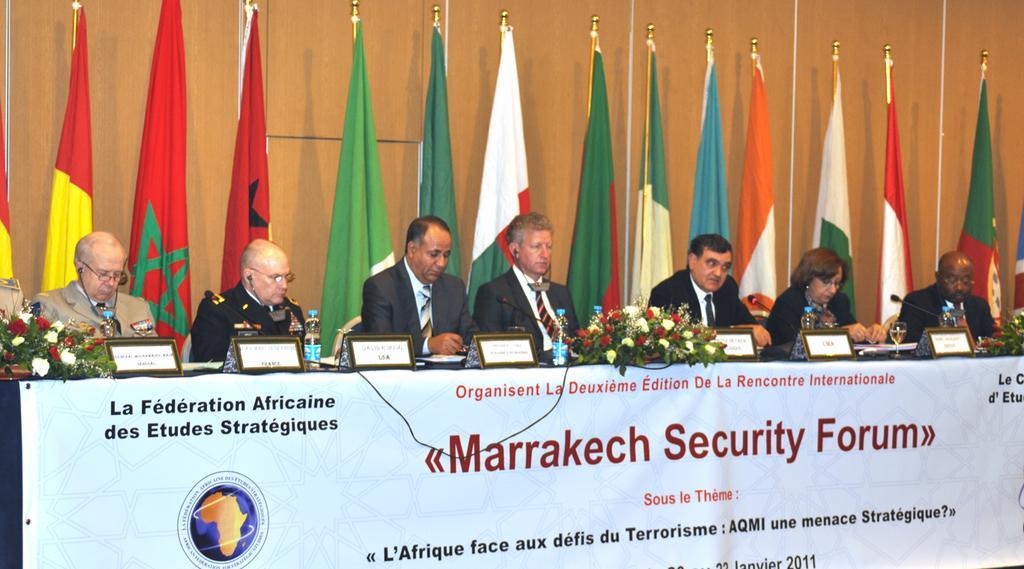How would you summarize this image in a sentence or two? In this image there are some persons sitting in middle of this image and are some flowers are kept on one table which is in middle, left and right side of this image. There are some flags at top of this image and there is a wall in the background and there is one table at bottom of this image and there is one white color board is attached to this table. 